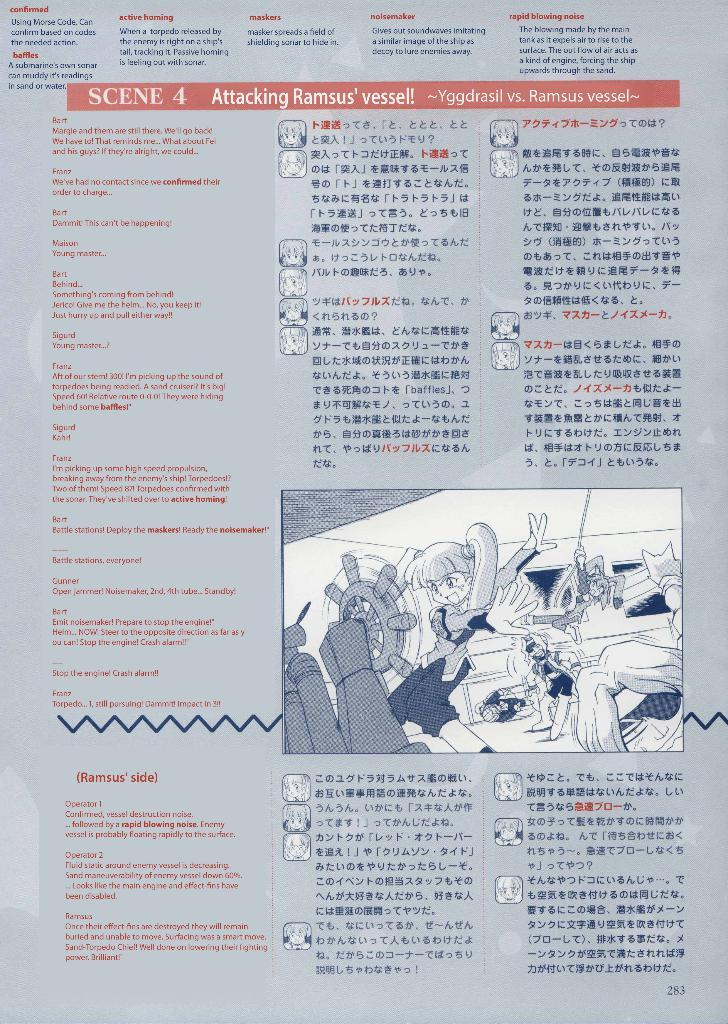Provide a one-sentence caption for the provided image. A translated page that is titled Attacking Ramsus' vessel!. 